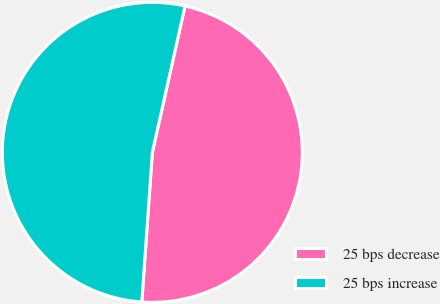<chart> <loc_0><loc_0><loc_500><loc_500><pie_chart><fcel>25 bps decrease<fcel>25 bps increase<nl><fcel>47.62%<fcel>52.38%<nl></chart> 